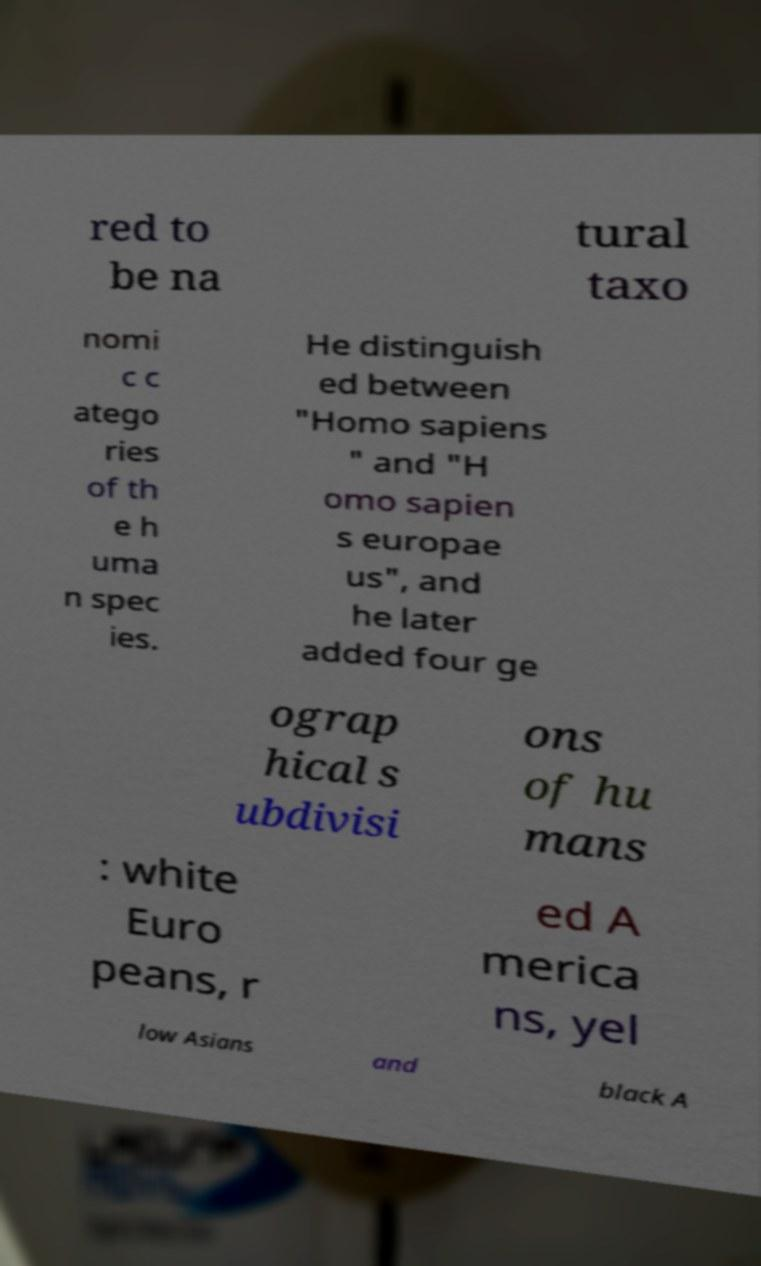Please identify and transcribe the text found in this image. red to be na tural taxo nomi c c atego ries of th e h uma n spec ies. He distinguish ed between "Homo sapiens " and "H omo sapien s europae us", and he later added four ge ograp hical s ubdivisi ons of hu mans : white Euro peans, r ed A merica ns, yel low Asians and black A 